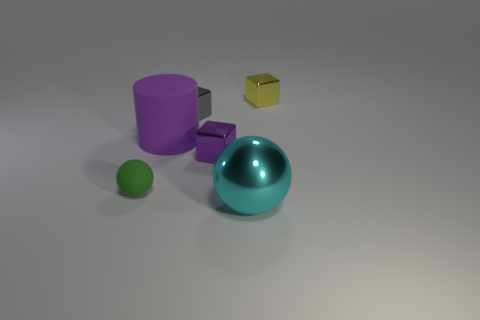The gray object that is the same material as the large sphere is what shape? cube 